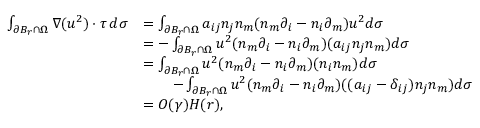<formula> <loc_0><loc_0><loc_500><loc_500>\begin{array} { r } { \begin{array} { r l } { \int _ { \partial B _ { r } \cap \Omega } \nabla ( u ^ { 2 } ) \cdot \tau \, d \sigma } & { = \int _ { \partial B _ { r } \cap \Omega } a _ { i j } n _ { j } n _ { m } ( n _ { m } \partial _ { i } - n _ { i } \partial _ { m } ) u ^ { 2 } d \sigma } \\ & { = - \int _ { \partial B _ { r } \cap \Omega } u ^ { 2 } ( n _ { m } \partial _ { i } - n _ { i } \partial _ { m } ) ( a _ { i j } n _ { j } n _ { m } ) d \sigma } \\ & { = \int _ { \partial B _ { r } \cap \Omega } u ^ { 2 } ( n _ { m } \partial _ { i } - n _ { i } \partial _ { m } ) ( n _ { i } n _ { m } ) d \sigma } \\ & { \quad - \int _ { \partial B _ { r } \cap \Omega } u ^ { 2 } ( n _ { m } \partial _ { i } - n _ { i } \partial _ { m } ) ( ( a _ { i j } - \delta _ { i j } ) n _ { j } n _ { m } ) d \sigma } \\ & { = O ( \gamma ) H ( r ) , } \end{array} } \end{array}</formula> 